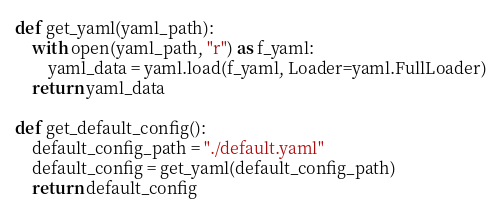<code> <loc_0><loc_0><loc_500><loc_500><_Python_>
def get_yaml(yaml_path):
    with open(yaml_path, "r") as f_yaml:
        yaml_data = yaml.load(f_yaml, Loader=yaml.FullLoader)
    return yaml_data

def get_default_config():
    default_config_path = "./default.yaml"
    default_config = get_yaml(default_config_path)
    return default_config
</code> 